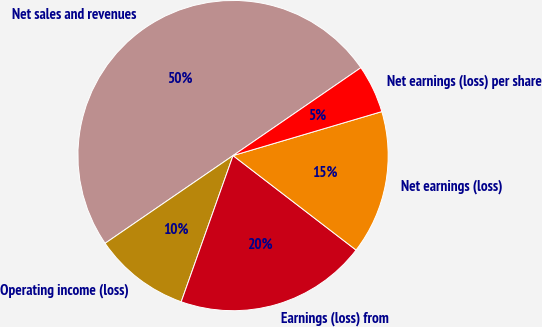Convert chart. <chart><loc_0><loc_0><loc_500><loc_500><pie_chart><fcel>Net sales and revenues<fcel>Operating income (loss)<fcel>Earnings (loss) from<fcel>Net earnings (loss)<fcel>Net earnings (loss) per share<nl><fcel>49.98%<fcel>10.01%<fcel>20.0%<fcel>15.0%<fcel>5.01%<nl></chart> 